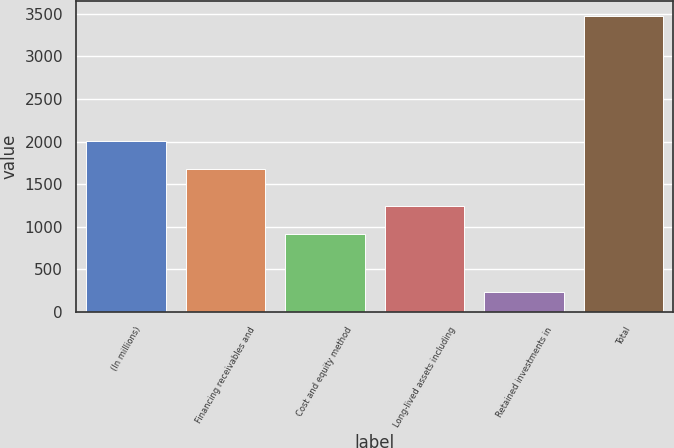Convert chart to OTSL. <chart><loc_0><loc_0><loc_500><loc_500><bar_chart><fcel>(In millions)<fcel>Financing receivables and<fcel>Cost and equity method<fcel>Long-lived assets including<fcel>Retained investments in<fcel>Total<nl><fcel>2009<fcel>1683<fcel>921<fcel>1244.7<fcel>237<fcel>3474<nl></chart> 